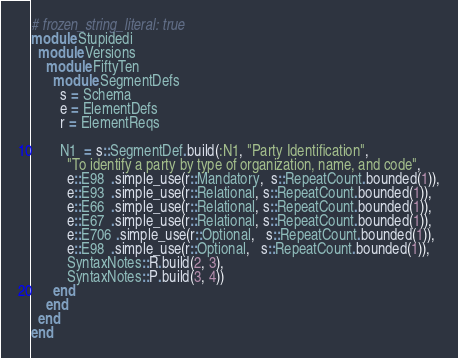Convert code to text. <code><loc_0><loc_0><loc_500><loc_500><_Ruby_># frozen_string_literal: true
module Stupidedi
  module Versions
    module FiftyTen
      module SegmentDefs
        s = Schema
        e = ElementDefs
        r = ElementReqs

        N1  = s::SegmentDef.build(:N1, "Party Identification",
          "To identify a party by type of organization, name, and code",
          e::E98  .simple_use(r::Mandatory,  s::RepeatCount.bounded(1)),
          e::E93  .simple_use(r::Relational, s::RepeatCount.bounded(1)),
          e::E66  .simple_use(r::Relational, s::RepeatCount.bounded(1)),
          e::E67  .simple_use(r::Relational, s::RepeatCount.bounded(1)),
          e::E706 .simple_use(r::Optional,   s::RepeatCount.bounded(1)),
          e::E98  .simple_use(r::Optional,   s::RepeatCount.bounded(1)),
          SyntaxNotes::R.build(2, 3),
          SyntaxNotes::P.build(3, 4))
      end
    end
  end
end
</code> 